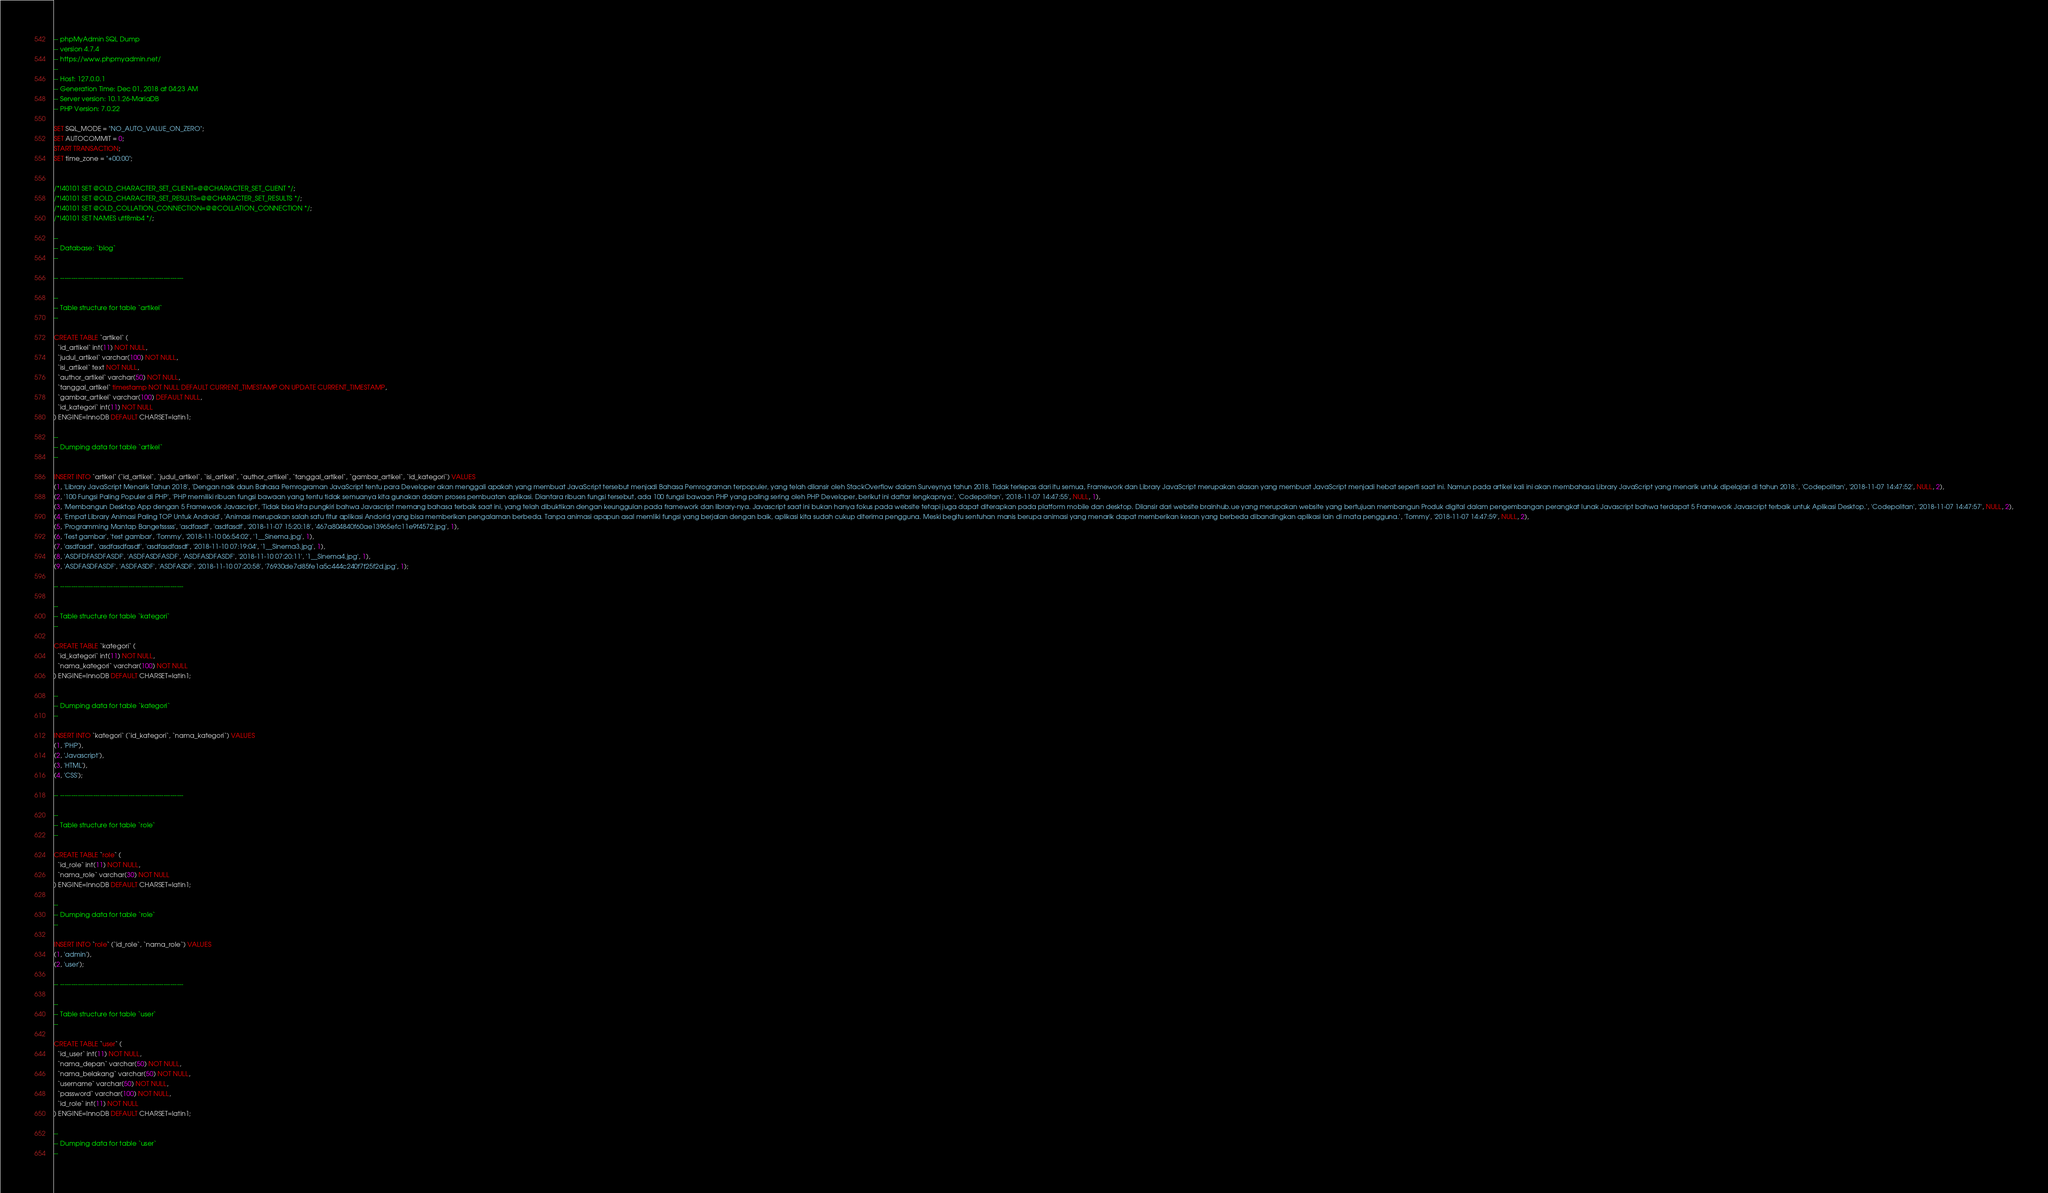<code> <loc_0><loc_0><loc_500><loc_500><_SQL_>-- phpMyAdmin SQL Dump
-- version 4.7.4
-- https://www.phpmyadmin.net/
--
-- Host: 127.0.0.1
-- Generation Time: Dec 01, 2018 at 04:23 AM
-- Server version: 10.1.26-MariaDB
-- PHP Version: 7.0.22

SET SQL_MODE = "NO_AUTO_VALUE_ON_ZERO";
SET AUTOCOMMIT = 0;
START TRANSACTION;
SET time_zone = "+00:00";


/*!40101 SET @OLD_CHARACTER_SET_CLIENT=@@CHARACTER_SET_CLIENT */;
/*!40101 SET @OLD_CHARACTER_SET_RESULTS=@@CHARACTER_SET_RESULTS */;
/*!40101 SET @OLD_COLLATION_CONNECTION=@@COLLATION_CONNECTION */;
/*!40101 SET NAMES utf8mb4 */;

--
-- Database: `blog`
--

-- --------------------------------------------------------

--
-- Table structure for table `artikel`
--

CREATE TABLE `artikel` (
  `id_artikel` int(11) NOT NULL,
  `judul_artikel` varchar(100) NOT NULL,
  `isi_artikel` text NOT NULL,
  `author_artikel` varchar(50) NOT NULL,
  `tanggal_artikel` timestamp NOT NULL DEFAULT CURRENT_TIMESTAMP ON UPDATE CURRENT_TIMESTAMP,
  `gambar_artikel` varchar(100) DEFAULT NULL,
  `id_kategori` int(11) NOT NULL
) ENGINE=InnoDB DEFAULT CHARSET=latin1;

--
-- Dumping data for table `artikel`
--

INSERT INTO `artikel` (`id_artikel`, `judul_artikel`, `isi_artikel`, `author_artikel`, `tanggal_artikel`, `gambar_artikel`, `id_kategori`) VALUES
(1, 'Library JavaScript Menarik Tahun 2018', 'Dengan naik daun Bahasa Pemrograman JavaScript tentu para Developer akan menggali apakah yang membuat JavaScript tersebut menjadi Bahasa Pemrograman terpopuler, yang telah dilansir oleh StackOverflow dalam Surveynya tahun 2018. Tidak terlepas dari itu semua, Framework dan Library JavaScript merupakan alasan yang membuat JavaScript menjadi hebat seperti saat ini. Namun pada artikel kali ini akan membahasa Library JavaScript yang menarik untuk dipelajari di tahun 2018.', 'Codepolitan', '2018-11-07 14:47:52', NULL, 2),
(2, '100 Fungsi Paling Populer di PHP', 'PHP memiliki ribuan fungsi bawaan yang tentu tidak semuanya kita gunakan dalam proses pembuatan aplikasi. Diantara ribuan fungsi tersebut, ada 100 fungsi bawaan PHP yang paling sering oleh PHP Developer, berikut ini daftar lengkapnya:', 'Codepolitan', '2018-11-07 14:47:55', NULL, 1),
(3, 'Membangun Desktop App dengan 5 Framework Javascript', 'Tidak bisa kita pungkiri bahwa Javascript memang bahasa terbaik saat ini, yang telah dibuktikan dengan keunggulan pada framework dan library-nya. Javascript saat ini bukan hanya fokus pada website tetapi juga dapat diterapkan pada platform mobile dan desktop. Dilansir dari website brainhub.ue yang merupakan website yang bertujuan membangun Produk digital dalam pengembangan perangkat lunak Javascript bahwa terdapat 5 Framework Javascript terbaik untuk Aplikasi Desktop.', 'Codepolitan', '2018-11-07 14:47:57', NULL, 2),
(4, 'Empat Library Animasi Paling TOP Untuk Android', 'Animasi merupakan salah satu fitur aplikasi Andorid yang bisa memberikan pengalaman berbeda. Tanpa animasi apapun asal memliki fungsi yang berjalan dengan baik, aplikasi kita sudah cukup diterima pengguna. Meski begitu sentuhan manis berupa animasi yang menarik dapat memberikan kesan yang berbeda dibandingkan aplikasi lain di mata pengguna.', 'Tommy', '2018-11-07 14:47:59', NULL, 2),
(5, 'Programming Mantap Bangetsssss', 'asdfasdf', 'asdfasdf', '2018-11-07 15:20:18', '467a804840f60ae13965efc11e9f4572.jpg', 1),
(6, 'Test gambar', 'test gambar', 'Tommy', '2018-11-10 06:54:02', '1__Sinema.jpg', 1),
(7, 'asdfasdf', 'asdfasdfasdf', 'asdfasdfasdf', '2018-11-10 07:19:04', '1__Sinema3.jpg', 1),
(8, 'ASDFDFASDFASDF', 'ASDFASDFASDF', 'ASDFASDFASDF', '2018-11-10 07:20:11', '1__Sinema4.jpg', 1),
(9, 'ASDFASDFASDF', 'ASDFASDF', 'ASDFASDF', '2018-11-10 07:20:58', '76930de7d85fe1a5c444c240f7f25f2d.jpg', 1);

-- --------------------------------------------------------

--
-- Table structure for table `kategori`
--

CREATE TABLE `kategori` (
  `id_kategori` int(11) NOT NULL,
  `nama_kategori` varchar(100) NOT NULL
) ENGINE=InnoDB DEFAULT CHARSET=latin1;

--
-- Dumping data for table `kategori`
--

INSERT INTO `kategori` (`id_kategori`, `nama_kategori`) VALUES
(1, 'PHP'),
(2, 'Javascript'),
(3, 'HTML'),
(4, 'CSS');

-- --------------------------------------------------------

--
-- Table structure for table `role`
--

CREATE TABLE `role` (
  `id_role` int(11) NOT NULL,
  `nama_role` varchar(30) NOT NULL
) ENGINE=InnoDB DEFAULT CHARSET=latin1;

--
-- Dumping data for table `role`
--

INSERT INTO `role` (`id_role`, `nama_role`) VALUES
(1, 'admin'),
(2, 'user');

-- --------------------------------------------------------

--
-- Table structure for table `user`
--

CREATE TABLE `user` (
  `id_user` int(11) NOT NULL,
  `nama_depan` varchar(50) NOT NULL,
  `nama_belakang` varchar(50) NOT NULL,
  `username` varchar(50) NOT NULL,
  `password` varchar(100) NOT NULL,
  `id_role` int(11) NOT NULL
) ENGINE=InnoDB DEFAULT CHARSET=latin1;

--
-- Dumping data for table `user`
--
</code> 